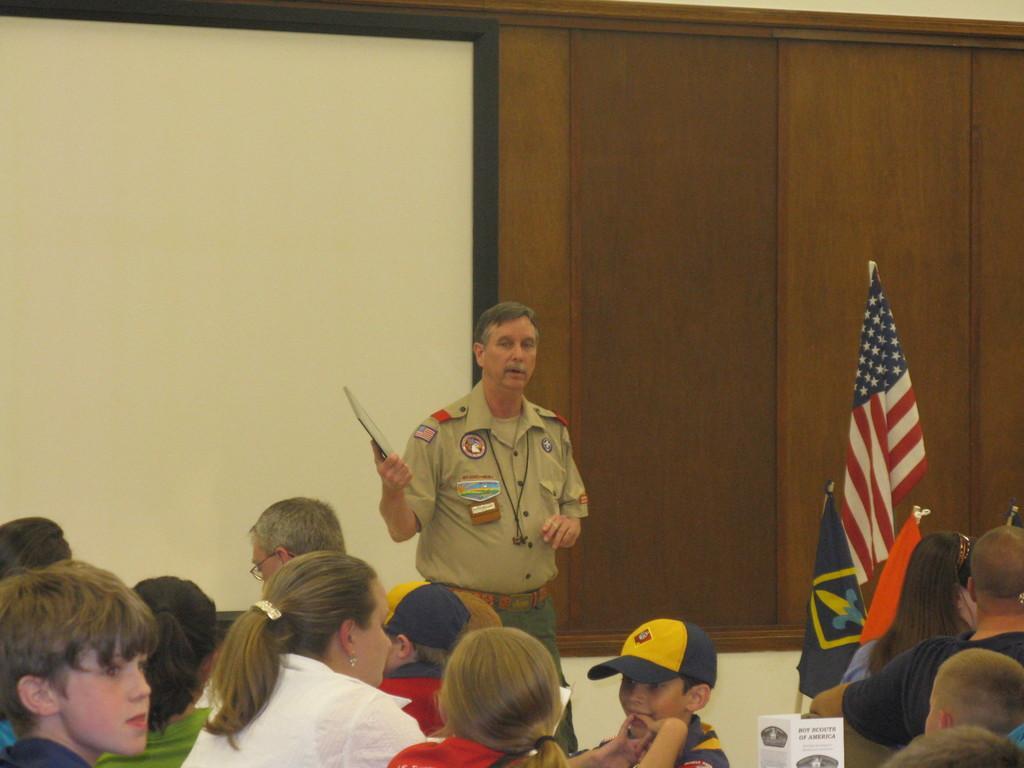How would you summarize this image in a sentence or two? In this image, we can see some people sitting and in the background, there is a man standing and holding an object, we can see some flags and there is a board. 